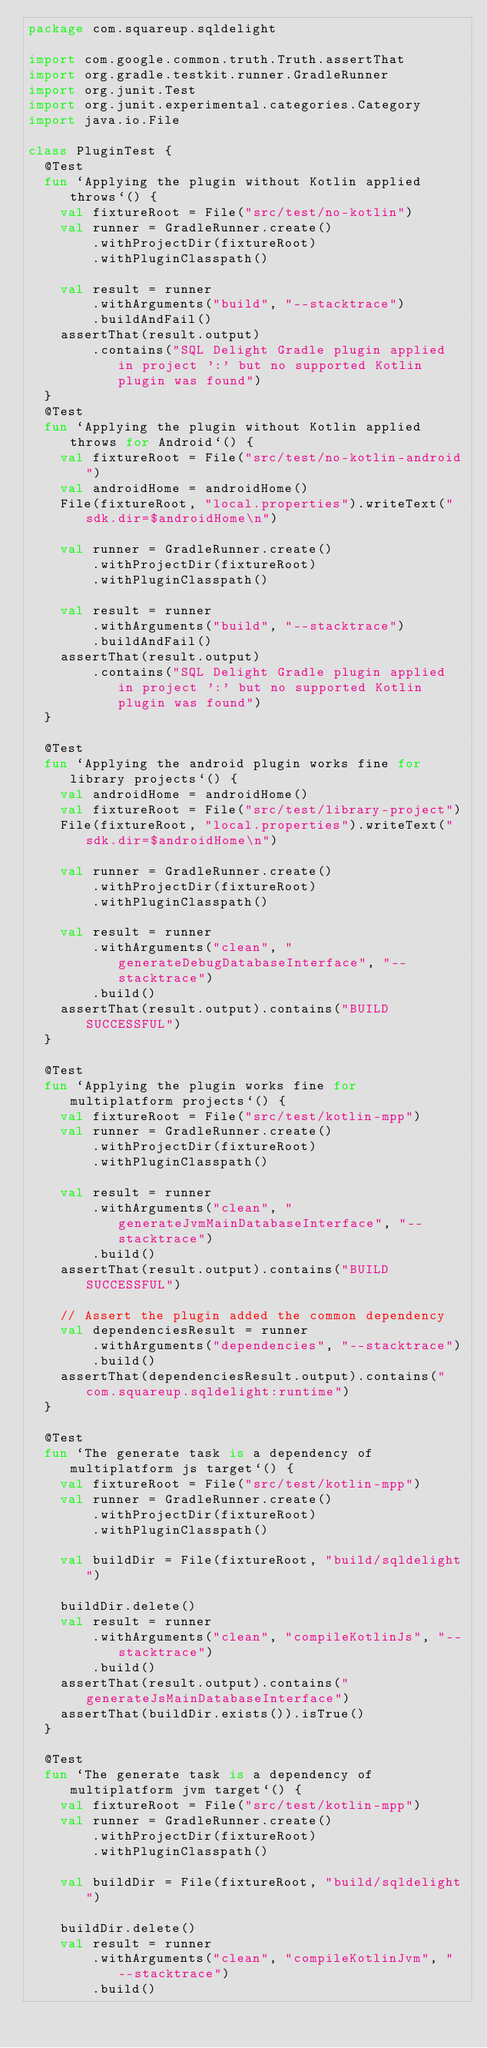<code> <loc_0><loc_0><loc_500><loc_500><_Kotlin_>package com.squareup.sqldelight

import com.google.common.truth.Truth.assertThat
import org.gradle.testkit.runner.GradleRunner
import org.junit.Test
import org.junit.experimental.categories.Category
import java.io.File

class PluginTest {
  @Test
  fun `Applying the plugin without Kotlin applied throws`() {
    val fixtureRoot = File("src/test/no-kotlin")
    val runner = GradleRunner.create()
        .withProjectDir(fixtureRoot)
        .withPluginClasspath()

    val result = runner
        .withArguments("build", "--stacktrace")
        .buildAndFail()
    assertThat(result.output)
        .contains("SQL Delight Gradle plugin applied in project ':' but no supported Kotlin plugin was found")
  }
  @Test
  fun `Applying the plugin without Kotlin applied throws for Android`() {
    val fixtureRoot = File("src/test/no-kotlin-android")
    val androidHome = androidHome()
    File(fixtureRoot, "local.properties").writeText("sdk.dir=$androidHome\n")

    val runner = GradleRunner.create()
        .withProjectDir(fixtureRoot)
        .withPluginClasspath()

    val result = runner
        .withArguments("build", "--stacktrace")
        .buildAndFail()
    assertThat(result.output)
        .contains("SQL Delight Gradle plugin applied in project ':' but no supported Kotlin plugin was found")
  }

  @Test
  fun `Applying the android plugin works fine for library projects`() {
    val androidHome = androidHome()
    val fixtureRoot = File("src/test/library-project")
    File(fixtureRoot, "local.properties").writeText("sdk.dir=$androidHome\n")

    val runner = GradleRunner.create()
        .withProjectDir(fixtureRoot)
        .withPluginClasspath()

    val result = runner
        .withArguments("clean", "generateDebugDatabaseInterface", "--stacktrace")
        .build()
    assertThat(result.output).contains("BUILD SUCCESSFUL")
  }

  @Test
  fun `Applying the plugin works fine for multiplatform projects`() {
    val fixtureRoot = File("src/test/kotlin-mpp")
    val runner = GradleRunner.create()
        .withProjectDir(fixtureRoot)
        .withPluginClasspath()

    val result = runner
        .withArguments("clean", "generateJvmMainDatabaseInterface", "--stacktrace")
        .build()
    assertThat(result.output).contains("BUILD SUCCESSFUL")

    // Assert the plugin added the common dependency
    val dependenciesResult = runner
        .withArguments("dependencies", "--stacktrace")
        .build()
    assertThat(dependenciesResult.output).contains("com.squareup.sqldelight:runtime")
  }

  @Test
  fun `The generate task is a dependency of multiplatform js target`() {
    val fixtureRoot = File("src/test/kotlin-mpp")
    val runner = GradleRunner.create()
        .withProjectDir(fixtureRoot)
        .withPluginClasspath()

    val buildDir = File(fixtureRoot, "build/sqldelight")

    buildDir.delete()
    val result = runner
        .withArguments("clean", "compileKotlinJs", "--stacktrace")
        .build()
    assertThat(result.output).contains("generateJsMainDatabaseInterface")
    assertThat(buildDir.exists()).isTrue()
  }

  @Test
  fun `The generate task is a dependency of multiplatform jvm target`() {
    val fixtureRoot = File("src/test/kotlin-mpp")
    val runner = GradleRunner.create()
        .withProjectDir(fixtureRoot)
        .withPluginClasspath()

    val buildDir = File(fixtureRoot, "build/sqldelight")

    buildDir.delete()
    val result = runner
        .withArguments("clean", "compileKotlinJvm", "--stacktrace")
        .build()</code> 